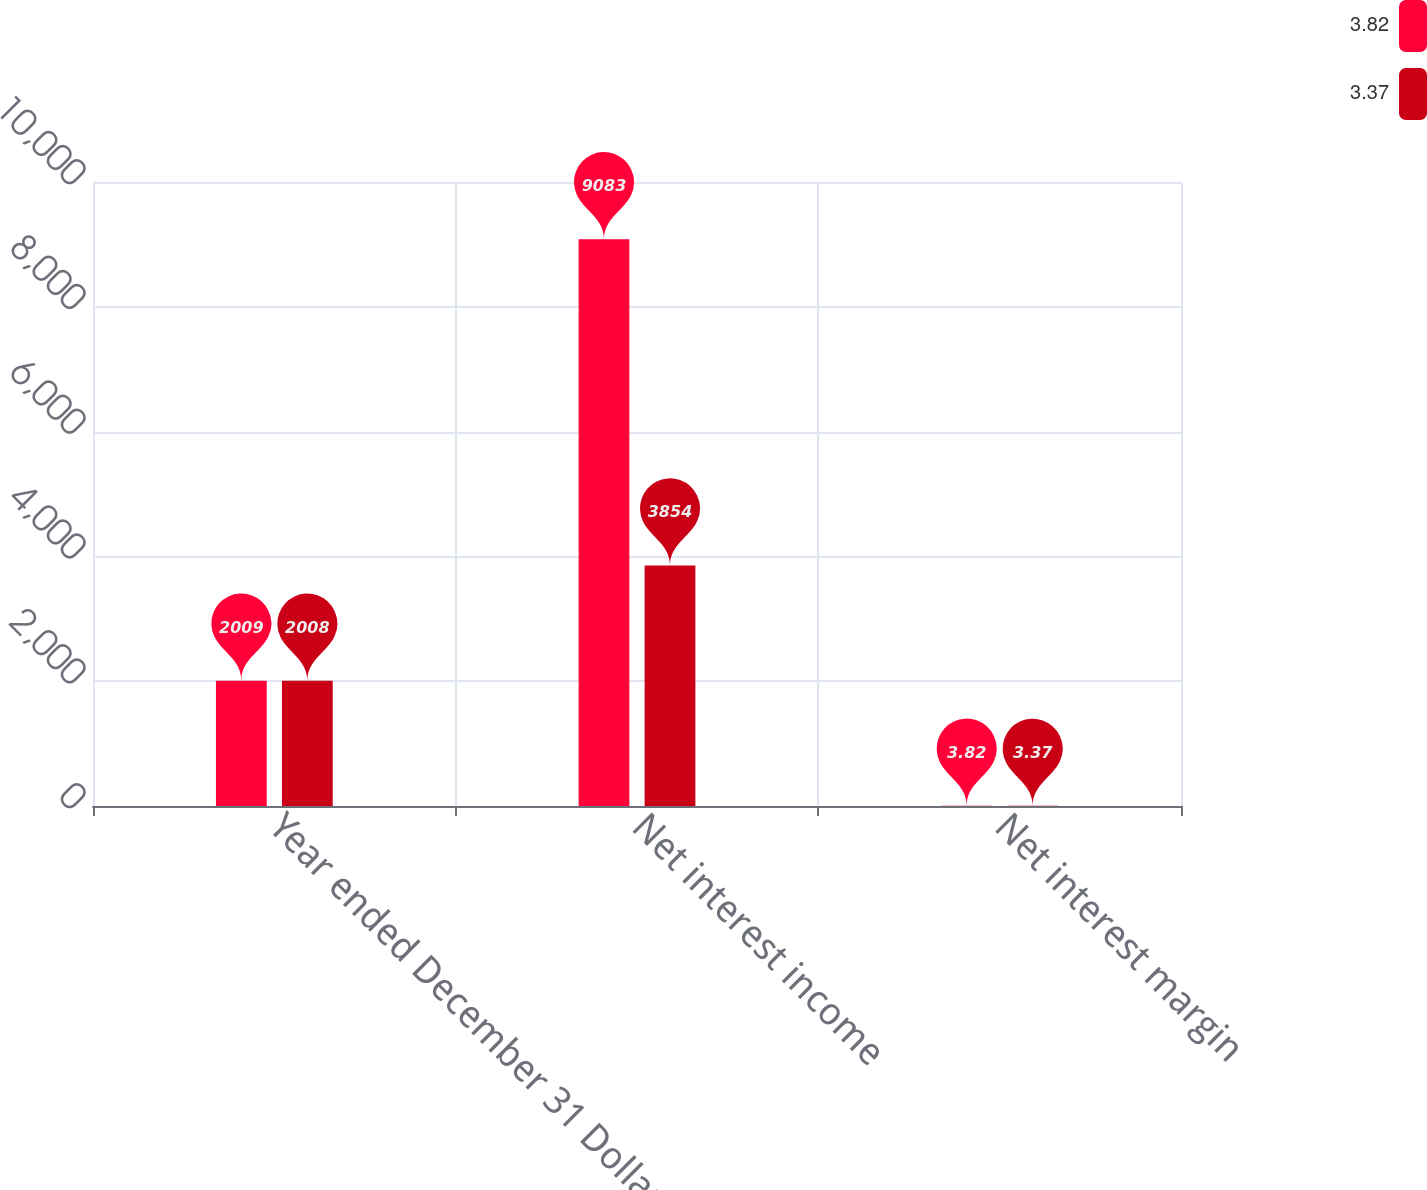Convert chart. <chart><loc_0><loc_0><loc_500><loc_500><stacked_bar_chart><ecel><fcel>Year ended December 31 Dollars<fcel>Net interest income<fcel>Net interest margin<nl><fcel>3.82<fcel>2009<fcel>9083<fcel>3.82<nl><fcel>3.37<fcel>2008<fcel>3854<fcel>3.37<nl></chart> 